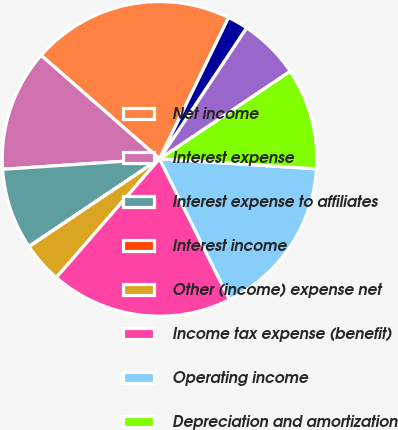Convert chart to OTSL. <chart><loc_0><loc_0><loc_500><loc_500><pie_chart><fcel>Net income<fcel>Interest expense<fcel>Interest expense to affiliates<fcel>Interest income<fcel>Other (income) expense net<fcel>Income tax expense (benefit)<fcel>Operating income<fcel>Depreciation and amortization<fcel>Stock-based compensation (1)<fcel>Other net (2)<nl><fcel>20.8%<fcel>12.49%<fcel>8.34%<fcel>0.03%<fcel>4.18%<fcel>18.73%<fcel>16.65%<fcel>10.42%<fcel>6.26%<fcel>2.1%<nl></chart> 